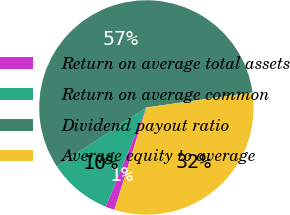<chart> <loc_0><loc_0><loc_500><loc_500><pie_chart><fcel>Return on average total assets<fcel>Return on average common<fcel>Dividend payout ratio<fcel>Average equity to average<nl><fcel>1.37%<fcel>9.53%<fcel>57.04%<fcel>32.05%<nl></chart> 